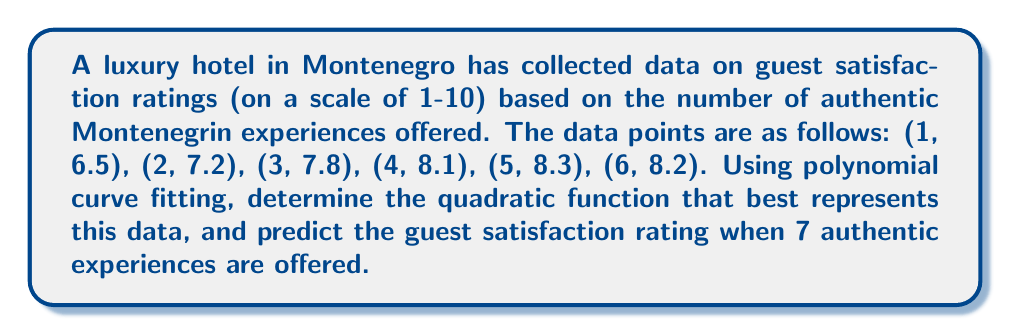Provide a solution to this math problem. To find the quadratic function that best fits the data, we'll use the method of least squares with a second-degree polynomial: $f(x) = ax^2 + bx + c$

Step 1: Set up the system of normal equations:
$$\begin{cases}
\sum x^4 a + \sum x^3 b + \sum x^2 c = \sum x^2 y \\
\sum x^3 a + \sum x^2 b + \sum x c = \sum xy \\
\sum x^2 a + \sum x b + n c = \sum y
\end{cases}$$

Step 2: Calculate the sums:
$\sum x = 21$, $\sum x^2 = 91$, $\sum x^3 = 441$, $\sum x^4 = 2275$
$\sum y = 46.1$, $\sum xy = 195.3$, $\sum x^2y = 849.9$
$n = 6$

Step 3: Substitute the values into the system of equations:
$$\begin{cases}
2275a + 441b + 91c = 849.9 \\
441a + 91b + 21c = 195.3 \\
91a + 21b + 6c = 46.1
\end{cases}$$

Step 4: Solve the system of equations (using a calculator or computer algebra system):
$a \approx -0.0833$, $b \approx 0.8333$, $c \approx 5.7833$

Step 5: Write the quadratic function:
$f(x) \approx -0.0833x^2 + 0.8333x + 5.7833$

Step 6: Predict the guest satisfaction rating for 7 authentic experiences:
$f(7) \approx -0.0833(7^2) + 0.8333(7) + 5.7833 \approx 8.1666$
Answer: $f(x) \approx -0.0833x^2 + 0.8333x + 5.7833$; $f(7) \approx 8.17$ 